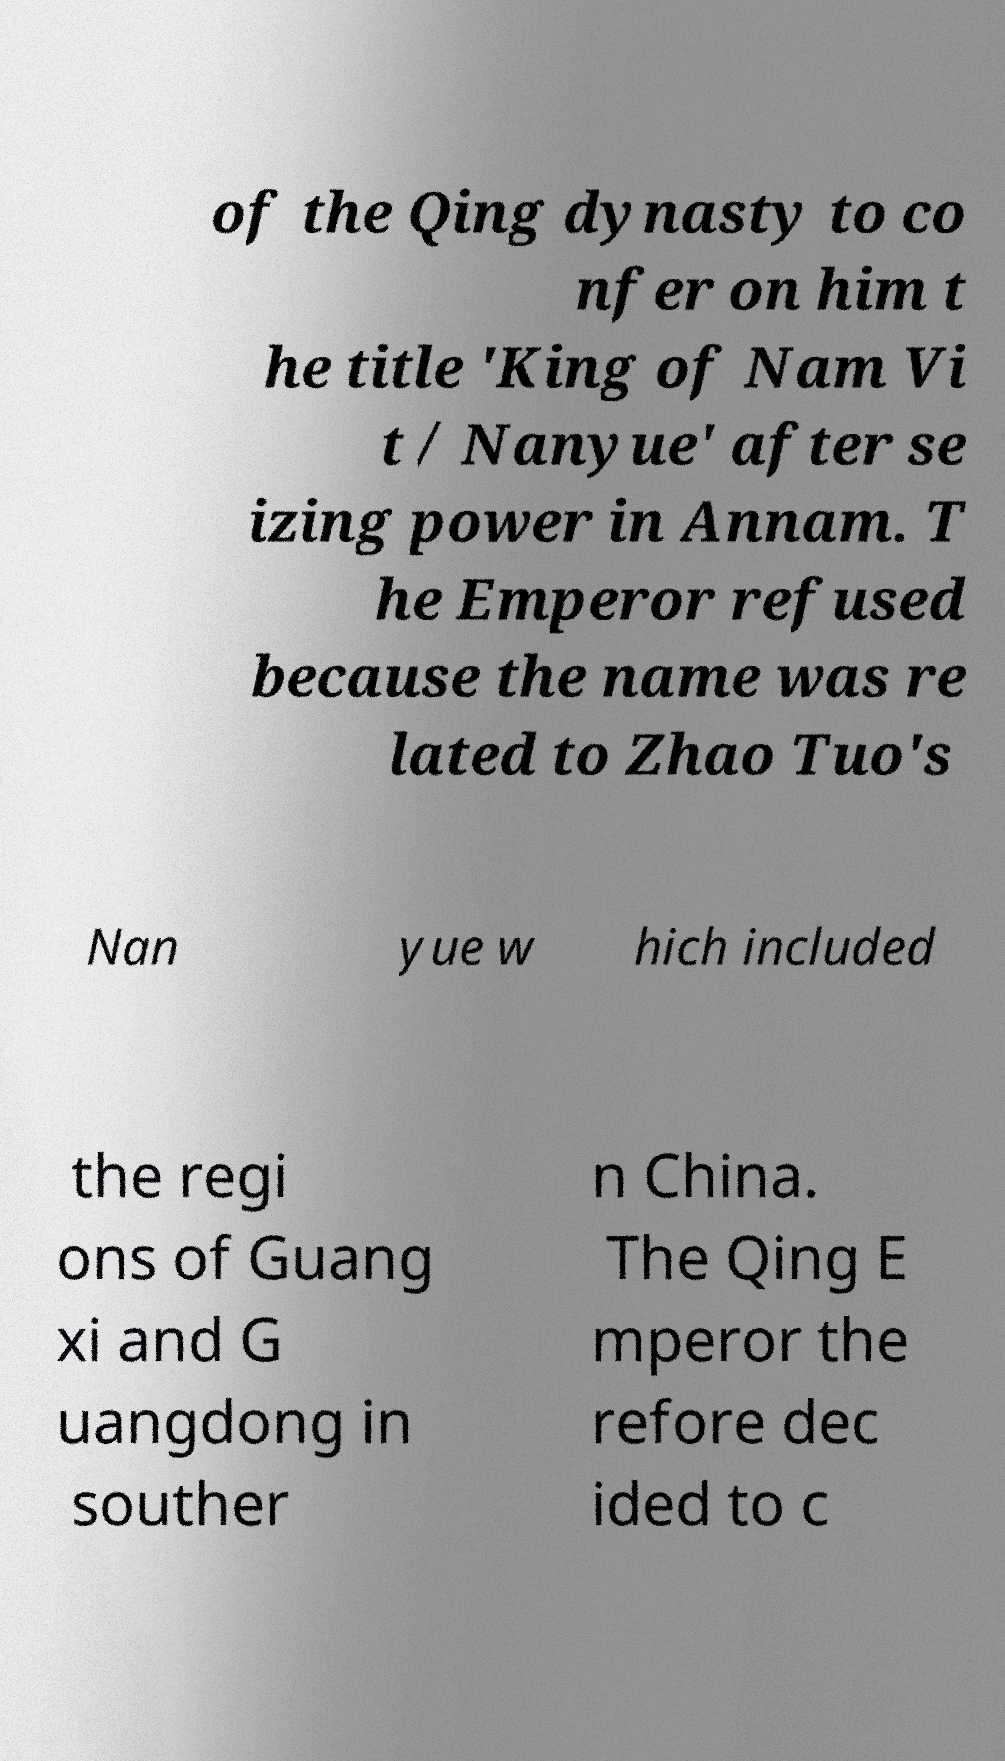Please read and relay the text visible in this image. What does it say? of the Qing dynasty to co nfer on him t he title 'King of Nam Vi t / Nanyue' after se izing power in Annam. T he Emperor refused because the name was re lated to Zhao Tuo's Nan yue w hich included the regi ons of Guang xi and G uangdong in souther n China. The Qing E mperor the refore dec ided to c 